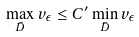<formula> <loc_0><loc_0><loc_500><loc_500>\max _ { \bar { D } } v _ { \epsilon } \leq C ^ { \prime } \min _ { \bar { D } } v _ { \epsilon }</formula> 